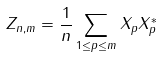Convert formula to latex. <formula><loc_0><loc_0><loc_500><loc_500>Z _ { n , m } = \frac { 1 } { n } \sum _ { 1 \leq p \leq m } X _ { p } X _ { p } ^ { * }</formula> 